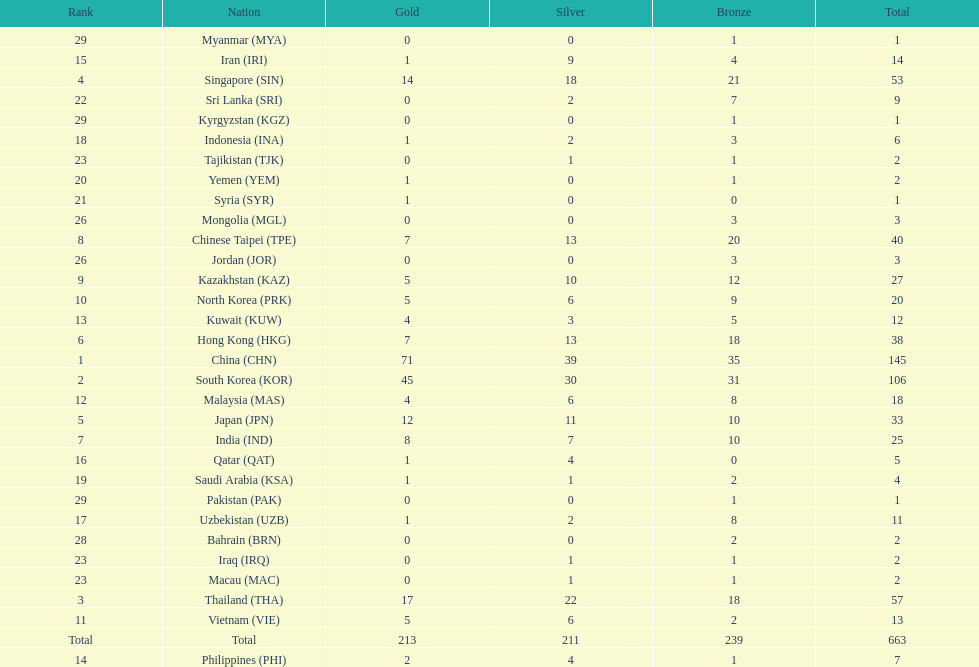How many countries have at least 10 gold medals in the asian youth games? 5. 